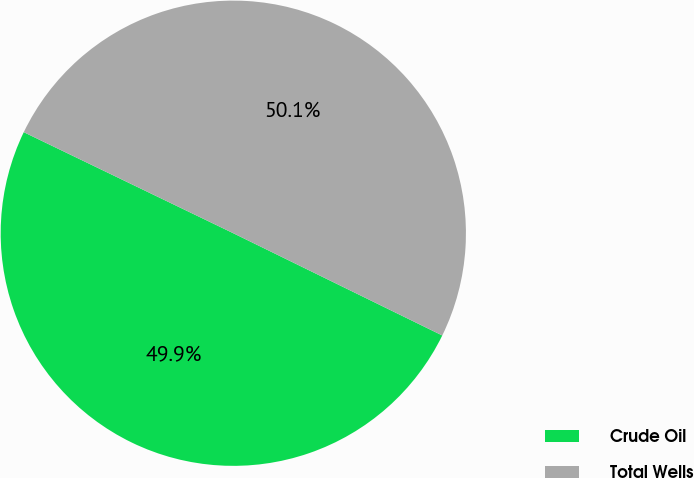Convert chart. <chart><loc_0><loc_0><loc_500><loc_500><pie_chart><fcel>Crude Oil<fcel>Total Wells<nl><fcel>49.91%<fcel>50.09%<nl></chart> 